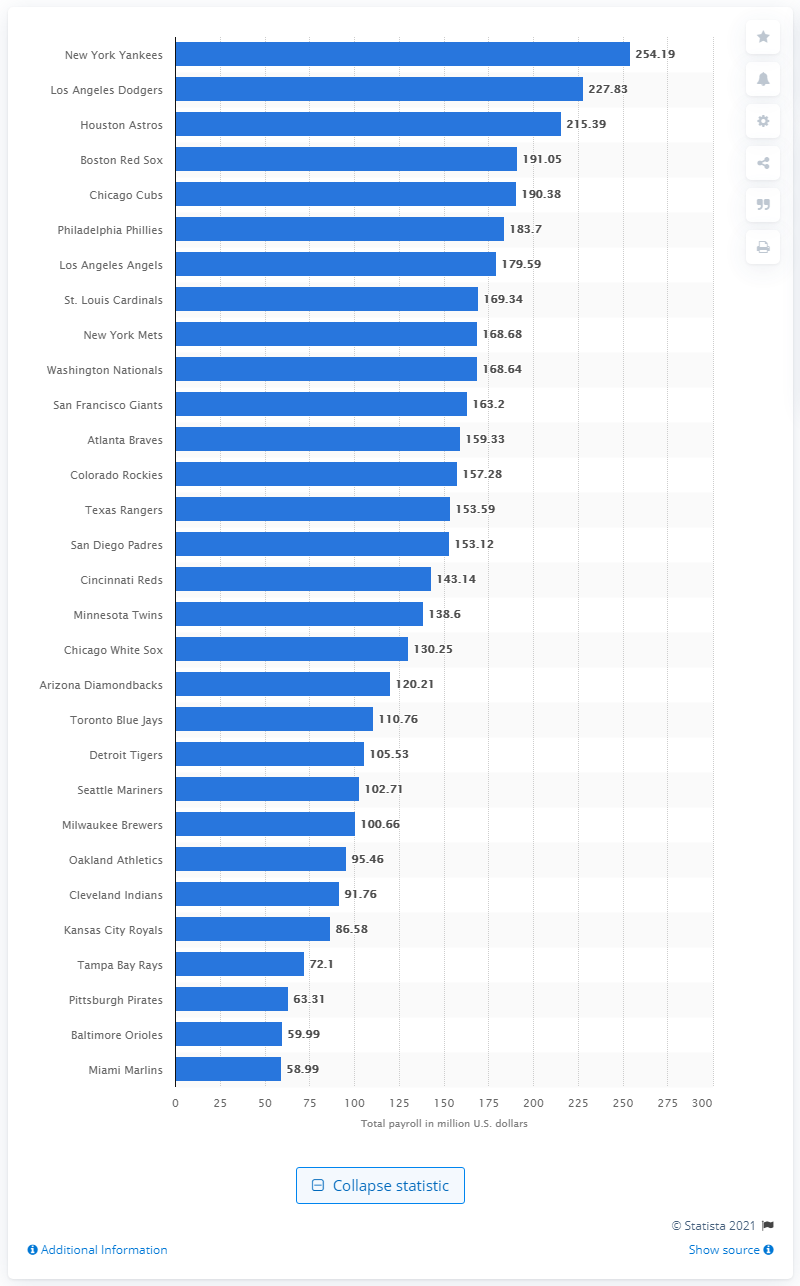Identify some key points in this picture. On the opening day of the Miami Marlins, the team's payroll was $58.99. The New York Yankees' payroll at the beginning of the 2020 season was $254.19 million. 